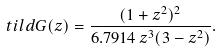<formula> <loc_0><loc_0><loc_500><loc_500>\ t i l d { G } ( z ) = \frac { ( 1 + z ^ { 2 } ) ^ { 2 } } { 6 . 7 9 1 4 \, z ^ { 3 } ( 3 - z ^ { 2 } ) } .</formula> 